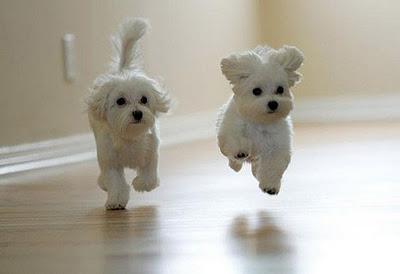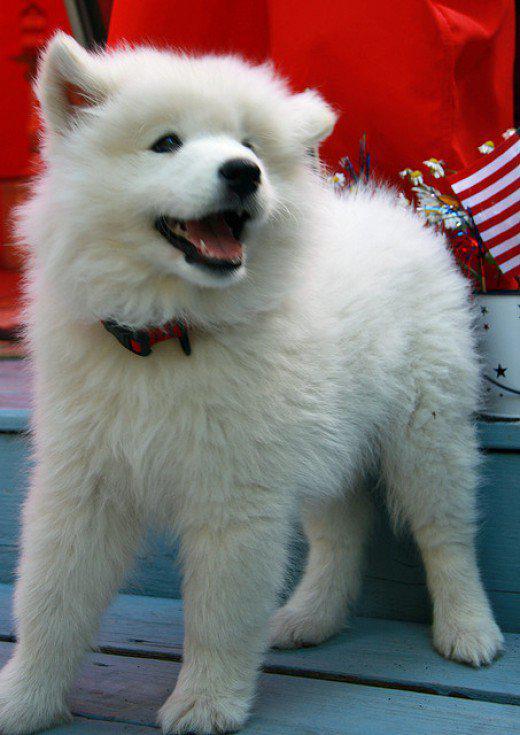The first image is the image on the left, the second image is the image on the right. Given the left and right images, does the statement "At least one dog has its mouth open." hold true? Answer yes or no. Yes. The first image is the image on the left, the second image is the image on the right. For the images displayed, is the sentence "A total of three white dogs are shown, and the two dogs in one image are lookalikes, but do not closely resemble the lone dog in the other image." factually correct? Answer yes or no. Yes. 